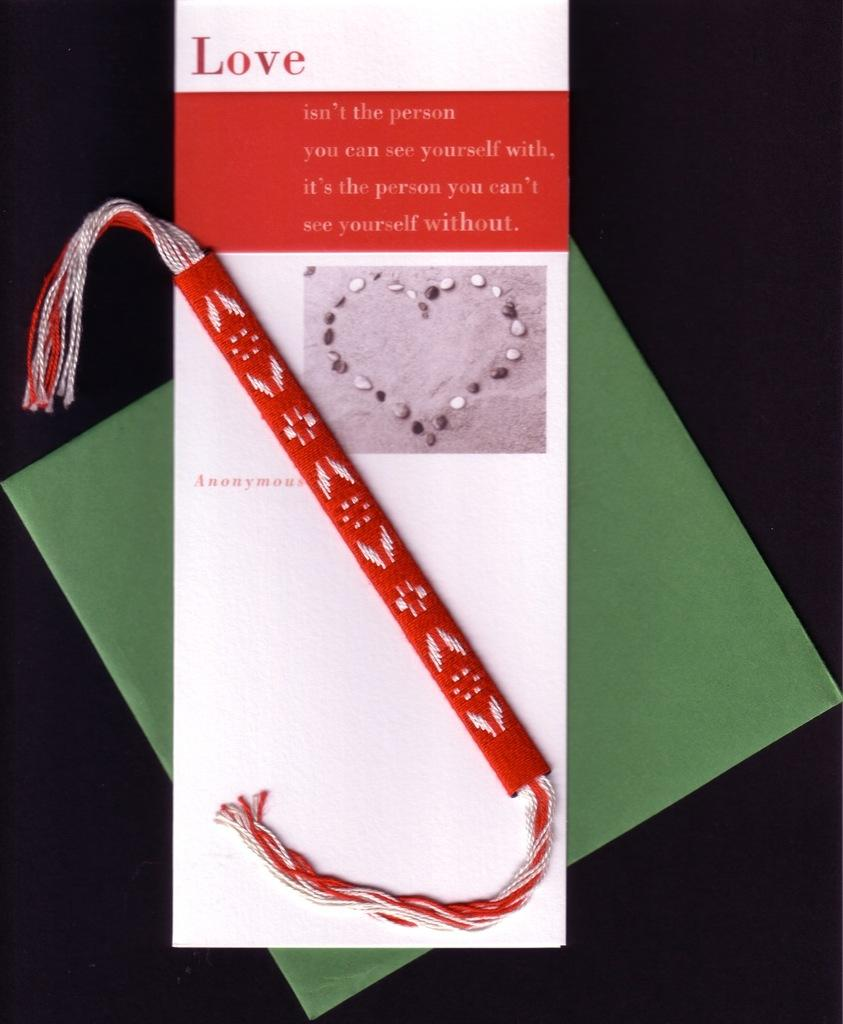<image>
Offer a succinct explanation of the picture presented. A bracelet is on top of a card that discusses love. 